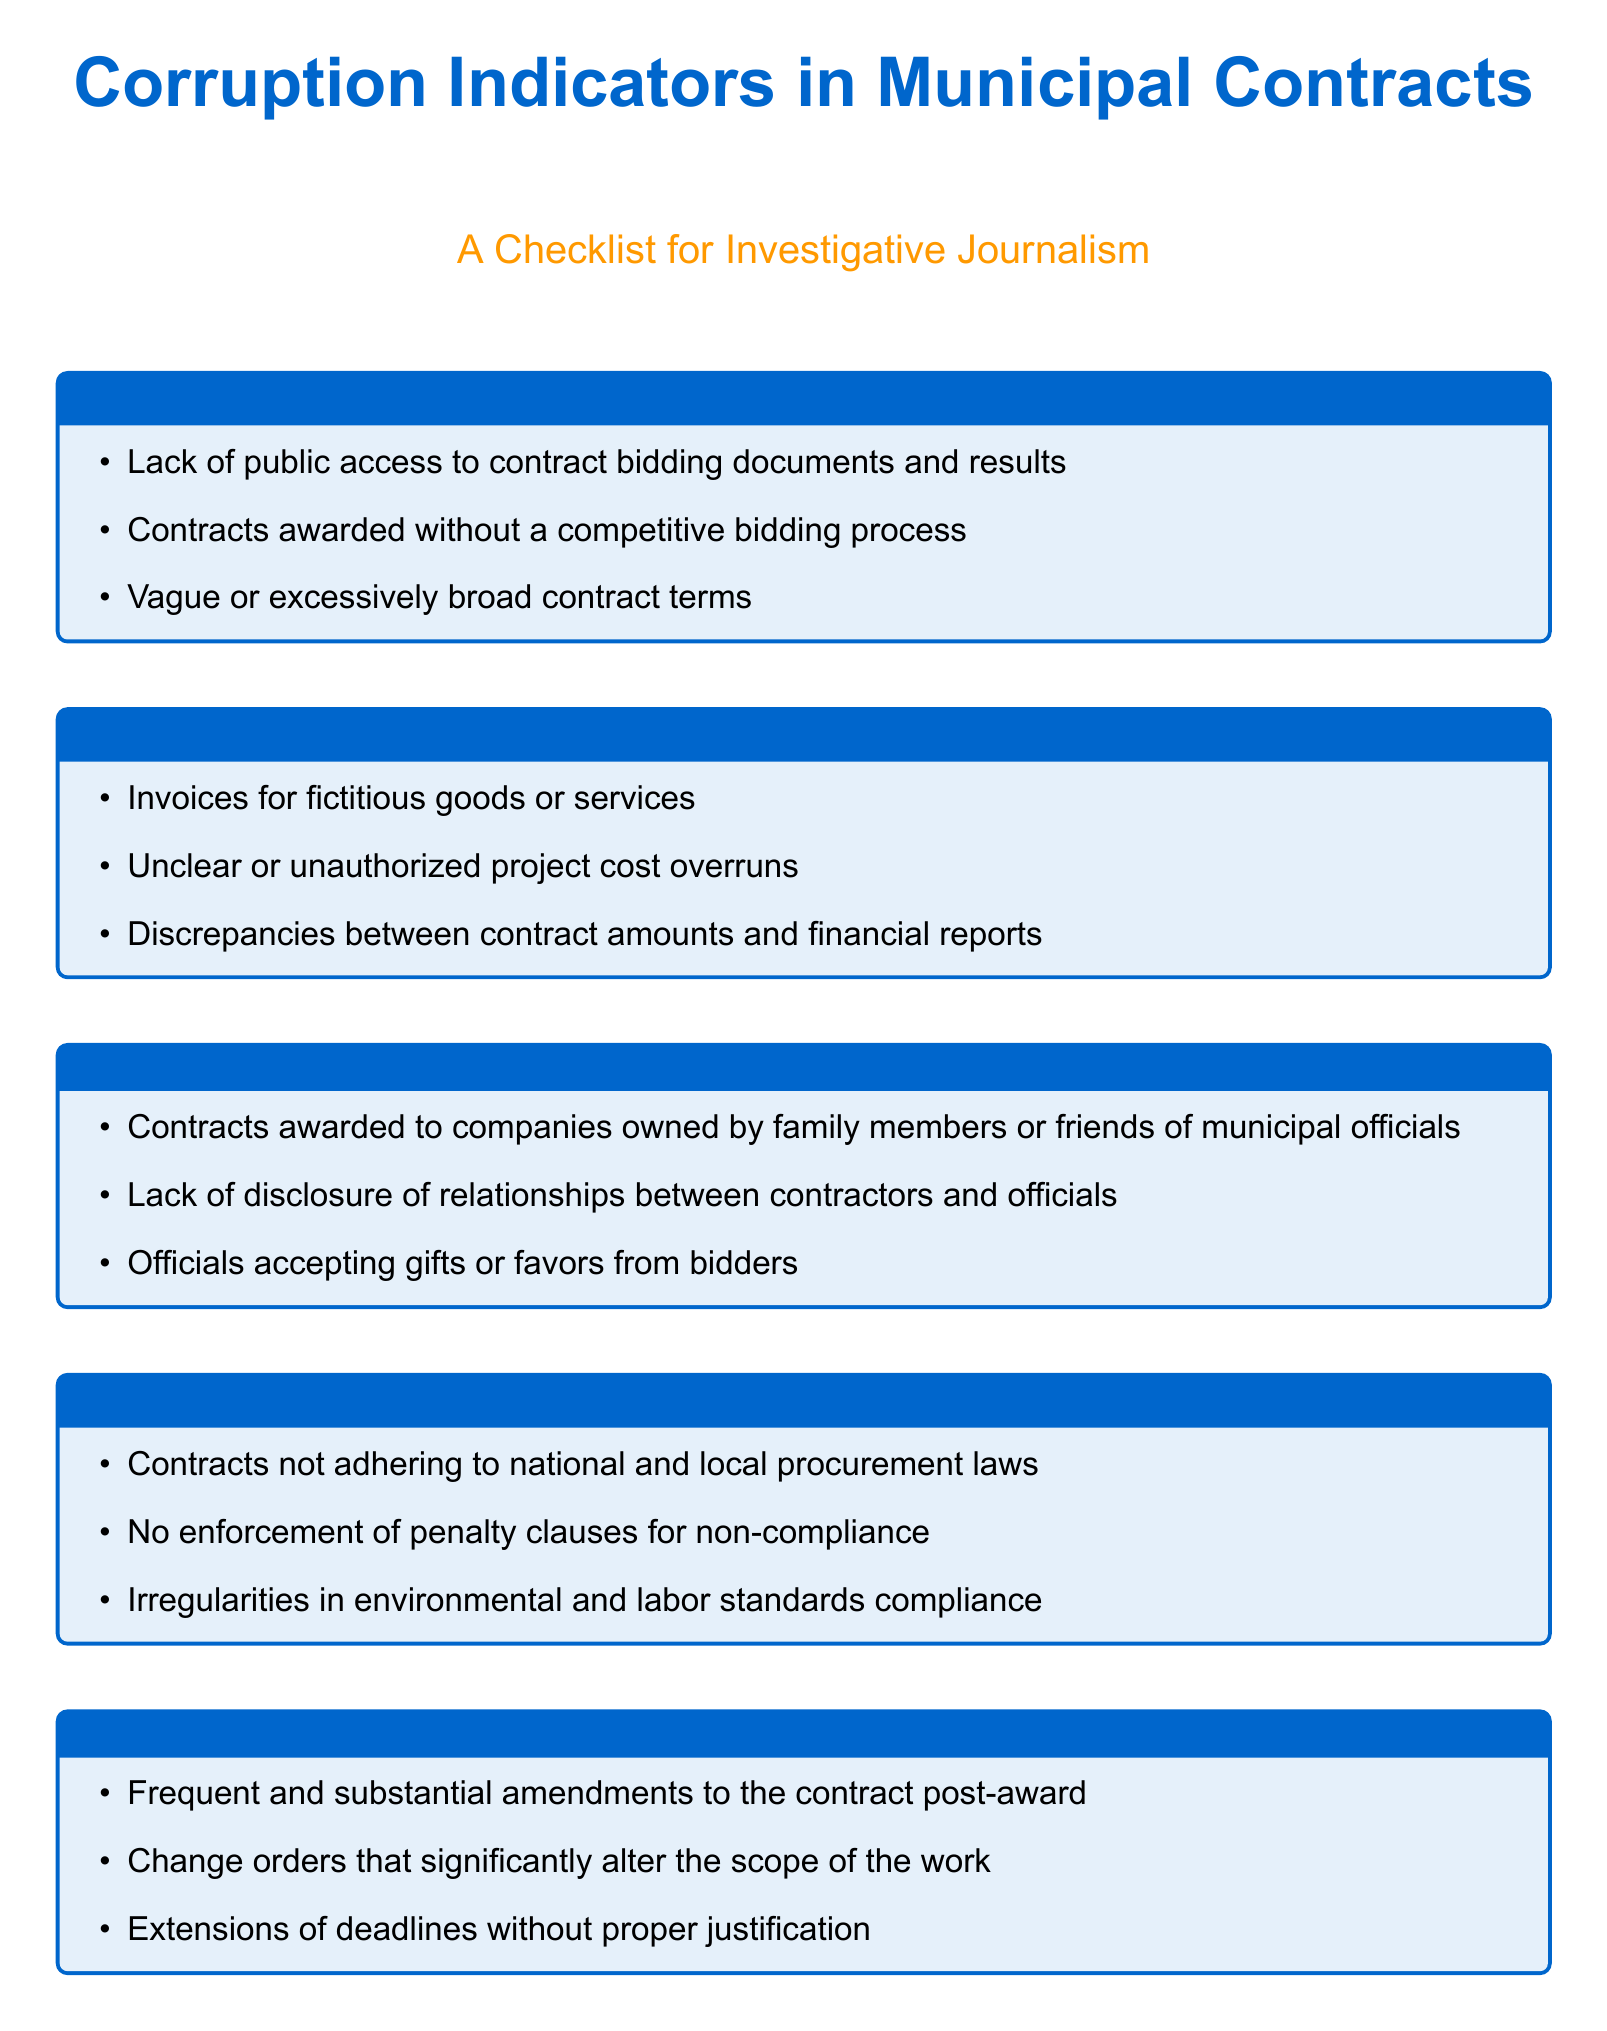What are the three categories of corruption indicators listed? The document lists categories such as Transparency Issues, Financial Irregularities, and Conflict of Interest.
Answer: Transparency Issues, Financial Irregularities, Conflict of Interest How many indicators are there under Non-Compliance with Legal Standards? The checklist features three specific indicators under this category.
Answer: Three What is one example of a financial irregularity mentioned? The document provides examples such as invoices for fictitious goods or services.
Answer: Invoices for fictitious goods or services What type of modifications are flagged as unusual? The document identifies frequent and substantial amendments to contracts as a red flag.
Answer: Frequent and substantial amendments What should project completions have to avoid being flagged? They should have valid explanations to avoid being flagged as delayed.
Answer: Valid explanations How many sections are included in the checklist? There are six distinct sections listed in the checklist document.
Answer: Six What does the term “contractors” relate to in context? It refers to companies or individuals who are awarded the municipal contracts.
Answer: Companies or individuals What is an example of transparency issue? The document cites the lack of public access to contract bidding documents as an example.
Answer: Lack of public access to contract bidding documents 